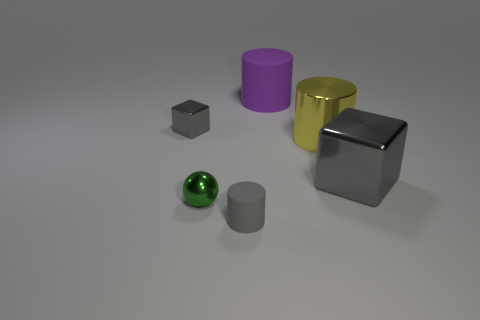The small gray object that is made of the same material as the large purple cylinder is what shape?
Your answer should be very brief. Cylinder. There is a gray shiny thing that is to the left of the gray cylinder; does it have the same size as the gray thing that is in front of the tiny green shiny object?
Keep it short and to the point. Yes. Is the number of large things that are right of the big rubber object greater than the number of small gray cylinders behind the green ball?
Ensure brevity in your answer.  Yes. What number of other objects are there of the same color as the sphere?
Your answer should be very brief. 0. Does the tiny block have the same color as the large shiny thing behind the large block?
Your answer should be compact. No. There is a gray block that is on the left side of the purple rubber object; what number of tiny things are in front of it?
Keep it short and to the point. 2. What material is the tiny gray thing that is in front of the gray cube that is on the right side of the cube to the left of the small gray matte thing made of?
Provide a short and direct response. Rubber. There is a cylinder that is in front of the tiny gray metal object and behind the ball; what material is it made of?
Your answer should be very brief. Metal. What number of large purple objects have the same shape as the large gray metallic object?
Make the answer very short. 0. How big is the matte cylinder that is behind the gray shiny cube that is in front of the tiny gray shiny block?
Your response must be concise. Large. 